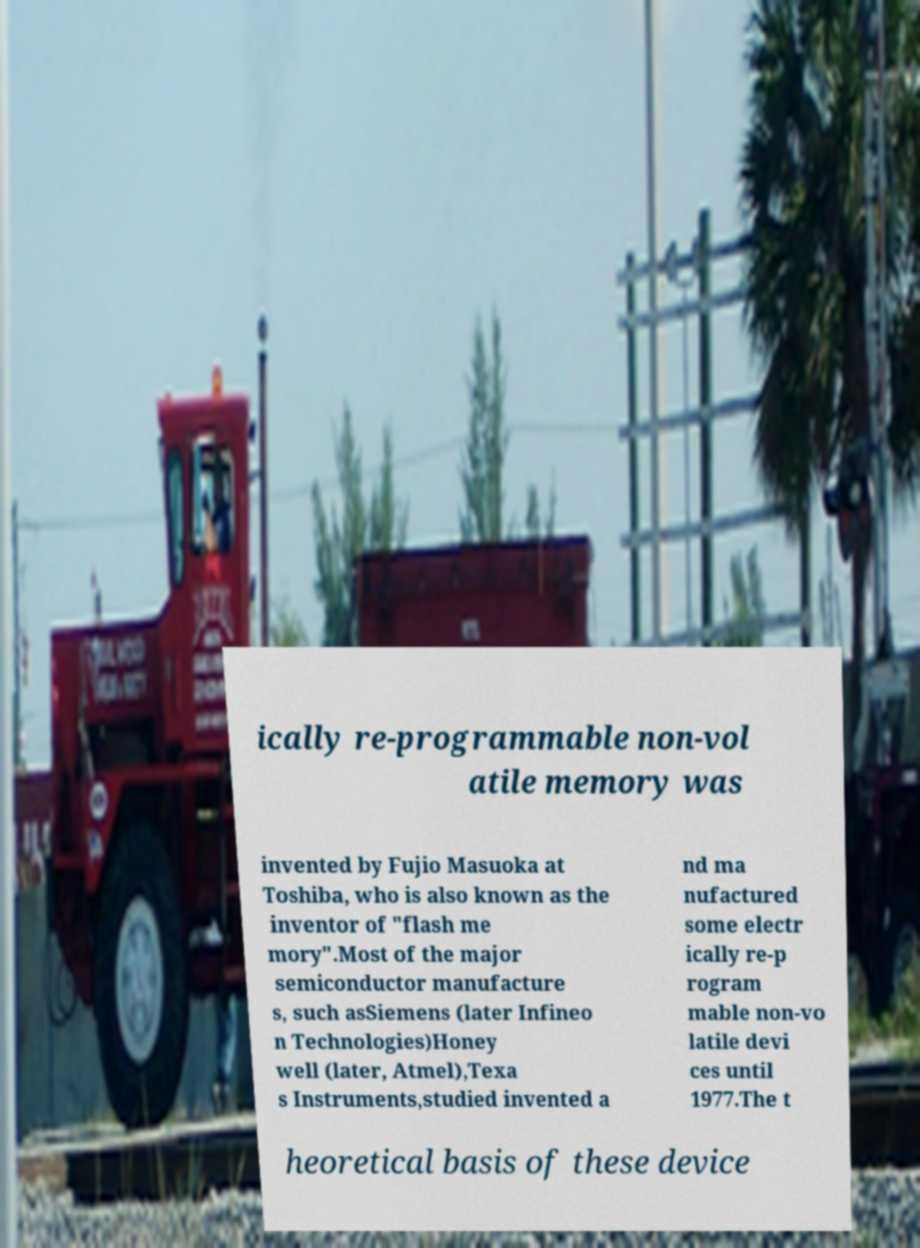Could you assist in decoding the text presented in this image and type it out clearly? ically re-programmable non-vol atile memory was invented by Fujio Masuoka at Toshiba, who is also known as the inventor of "flash me mory".Most of the major semiconductor manufacture s, such asSiemens (later Infineo n Technologies)Honey well (later, Atmel),Texa s Instruments,studied invented a nd ma nufactured some electr ically re-p rogram mable non-vo latile devi ces until 1977.The t heoretical basis of these device 